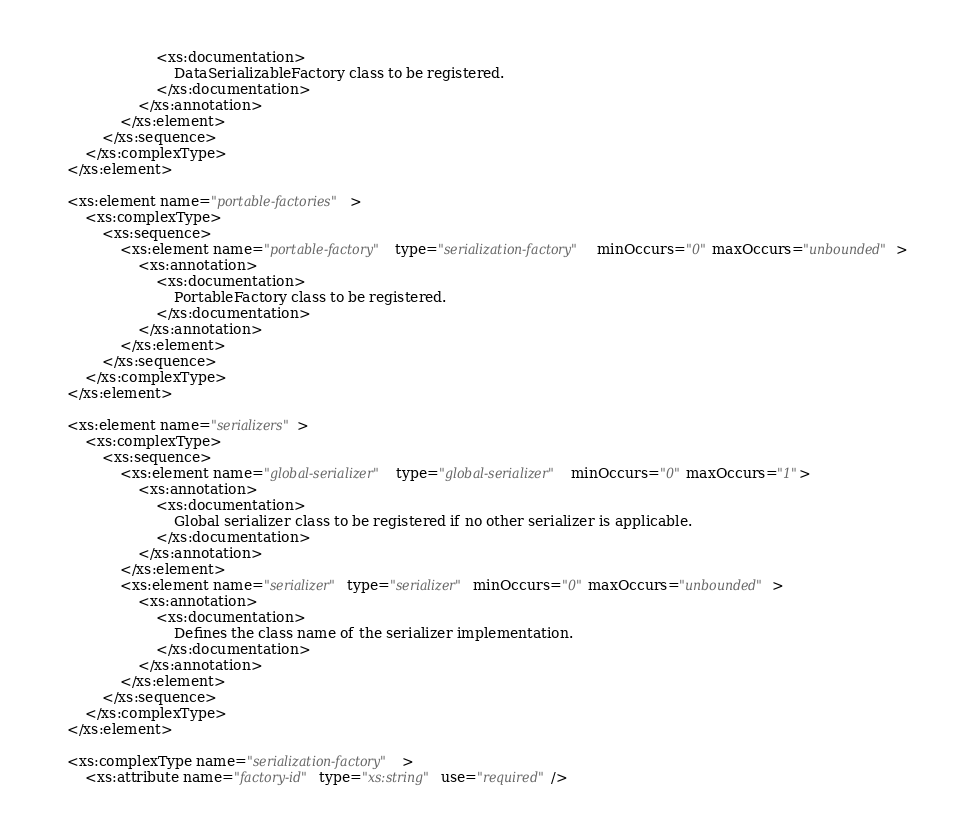Convert code to text. <code><loc_0><loc_0><loc_500><loc_500><_XML_>                        <xs:documentation>
                            DataSerializableFactory class to be registered.
                        </xs:documentation>
                    </xs:annotation>
                </xs:element>
            </xs:sequence>
        </xs:complexType>
    </xs:element>

    <xs:element name="portable-factories">
        <xs:complexType>
            <xs:sequence>
                <xs:element name="portable-factory" type="serialization-factory" minOccurs="0" maxOccurs="unbounded">
                    <xs:annotation>
                        <xs:documentation>
                            PortableFactory class to be registered.
                        </xs:documentation>
                    </xs:annotation>
                </xs:element>
            </xs:sequence>
        </xs:complexType>
    </xs:element>

    <xs:element name="serializers">
        <xs:complexType>
            <xs:sequence>
                <xs:element name="global-serializer" type="global-serializer" minOccurs="0" maxOccurs="1">
                    <xs:annotation>
                        <xs:documentation>
                            Global serializer class to be registered if no other serializer is applicable.
                        </xs:documentation>
                    </xs:annotation>
                </xs:element>
                <xs:element name="serializer" type="serializer" minOccurs="0" maxOccurs="unbounded">
                    <xs:annotation>
                        <xs:documentation>
                            Defines the class name of the serializer implementation.
                        </xs:documentation>
                    </xs:annotation>
                </xs:element>
            </xs:sequence>
        </xs:complexType>
    </xs:element>

    <xs:complexType name="serialization-factory">
        <xs:attribute name="factory-id" type="xs:string" use="required"/></code> 